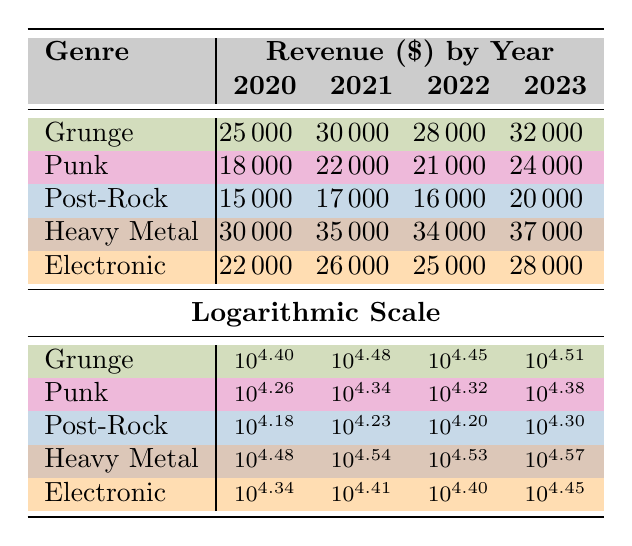What was the revenue from merchandise sales for Grunge in 2023? The table shows that the revenue for the genre Grunge in the year 2023 is 32000.
Answer: 32000 What genre had the highest merchandise sales revenue in 2021? The table indicates Heavy Metal as the category with the highest revenue in 2021 at 35000, compared to other genres which have lower values.
Answer: Heavy Metal What is the average revenue for Punk merchandise sales from 2020 to 2023? To find the average, add the revenues: (18000 + 22000 + 21000 + 24000) = 85000, and then divide by 4 (the number of years), resulting in 85000 / 4 = 21250.
Answer: 21250 Did Electronic merchandise sales increase every year from 2020 to 2023? Reviewing the values for Electronic, they are 22000, 26000, 25000, and 28000; the value decreased from 2021 to 2022 but increased again in 2023. Therefore, the statement is false.
Answer: No What is the total revenue from merchandise sales for Heavy Metal from 2020 to 2023? The total is calculated by summing the revenues: (30000 + 35000 + 34000 + 37000) = 136000.
Answer: 136000 Which genre saw the largest percentage increase in revenue from 2020 to 2023? Grunge had revenue of 25000 in 2020 and 32000 in 2023, which equates to a percentage increase of [(32000 - 25000) / 25000] * 100 = 28%. Heavy Metal saw a percentage increase of [(37000 - 30000) / 30000] * 100 = 23.33%. The greatest percentage increase is in Grunge.
Answer: Grunge In which year did Post-Rock generate its lowest revenue during these four years? By examining the revenues of Post-Rock: 15000, 17000, 16000, and 20000, the lowest value is 15000, occurring in 2020.
Answer: 2020 What was the revenue difference between Heavy Metal and Electronic in 2022? Heavy Metal's revenue in 2022 was 34000 while Electronic's was 25000. The difference can be found by calculating (34000 - 25000) = 9000.
Answer: 9000 